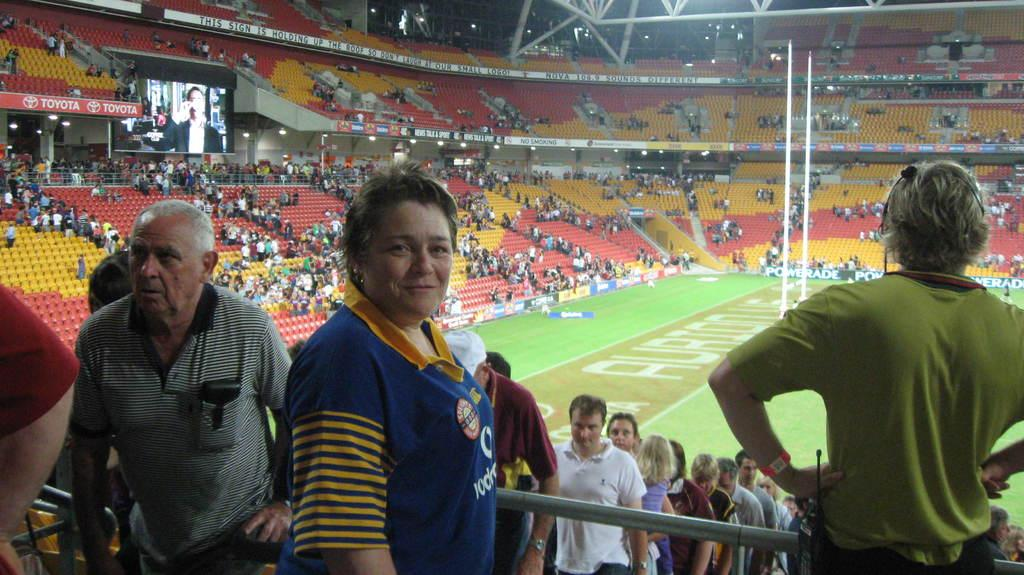How many people are in the image? There is a group of people in the image, but the exact number is not specified. What are the people in the image doing? Some people are seated, while others are standing. What can be seen on the left side of the image? There is a screen on the left side of the image. What type of objects can be seen in the background of the image? There are metal rods visible in the background of the image. What shape is the blow requesting in the image? There is no blow or request present in the image. What type of shape is the metal rod forming in the background? The metal rods in the background do not form a specific shape; they are simply visible objects. 